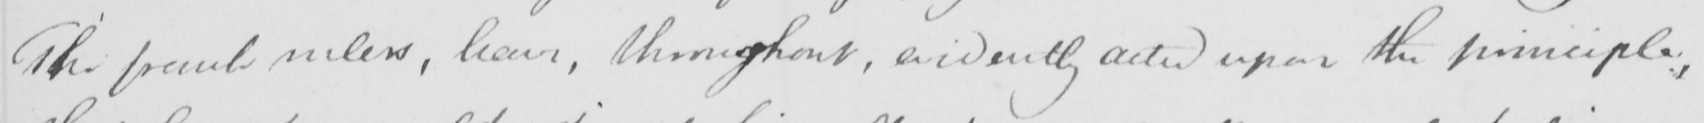Please transcribe the handwritten text in this image. The french rulers , have , throughout , evidently acted upon the principle , 